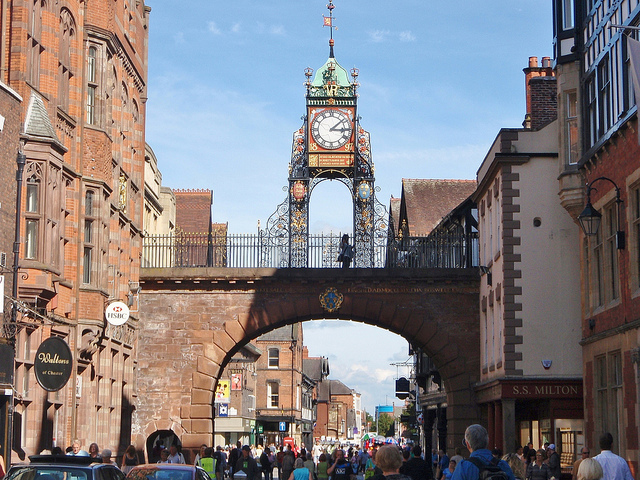<image>Which person is wearing a backpack? I don't know which person is wearing a backpack. It could be the man in blue shirt or the left person. Which city was this photo taken? It is ambiguous which city the photo was taken in. It could be any between London, Rome, Los Angeles, Prague, Chicago, Amsterdam, Venice, or Spain. Which person is wearing a backpack? I don't know which person is wearing a backpack. It can be any of the mentioned persons. Which city was this photo taken? I don't know which city this photo was taken. It can be any of the mentioned cities. 